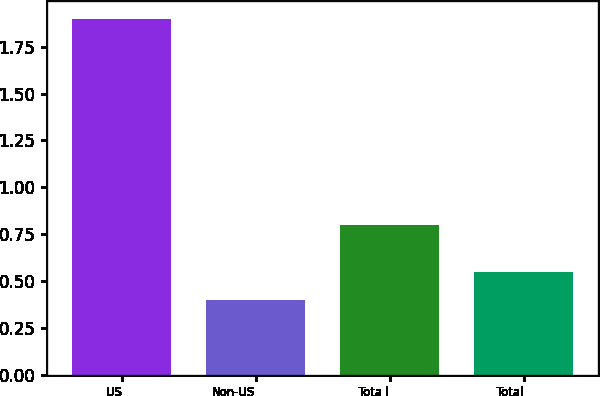Convert chart to OTSL. <chart><loc_0><loc_0><loc_500><loc_500><bar_chart><fcel>US<fcel>Non-US<fcel>Tota l<fcel>Total<nl><fcel>1.9<fcel>0.4<fcel>0.8<fcel>0.55<nl></chart> 